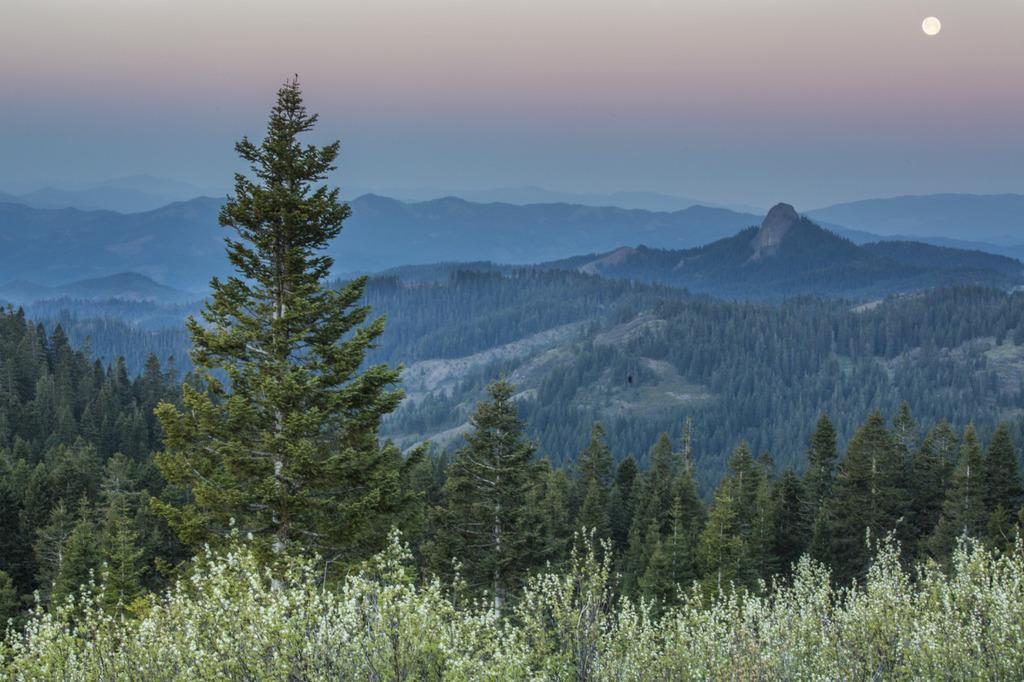What type of natural elements can be seen in the image? There are trees in the image. What type of landscape feature is visible in the background of the image? There are mountains visible in the background of the image. What part of the natural environment is visible in the background of the image? The sky is visible in the background of the image. How many women are sitting on the chairs in the image? There are no women or chairs present in the image. 